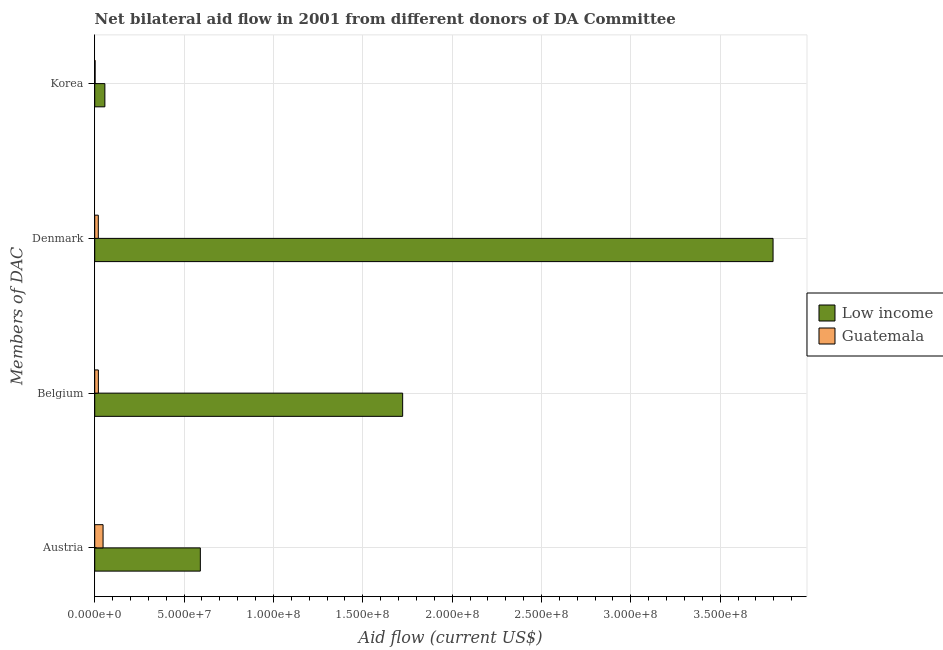Are the number of bars per tick equal to the number of legend labels?
Your answer should be very brief. Yes. How many bars are there on the 1st tick from the bottom?
Give a very brief answer. 2. What is the amount of aid given by denmark in Low income?
Offer a very short reply. 3.80e+08. Across all countries, what is the maximum amount of aid given by austria?
Your answer should be compact. 5.91e+07. Across all countries, what is the minimum amount of aid given by belgium?
Make the answer very short. 2.04e+06. In which country was the amount of aid given by denmark minimum?
Your answer should be compact. Guatemala. What is the total amount of aid given by korea in the graph?
Keep it short and to the point. 5.89e+06. What is the difference between the amount of aid given by denmark in Guatemala and that in Low income?
Provide a short and direct response. -3.78e+08. What is the difference between the amount of aid given by austria in Low income and the amount of aid given by belgium in Guatemala?
Keep it short and to the point. 5.71e+07. What is the average amount of aid given by denmark per country?
Keep it short and to the point. 1.91e+08. What is the difference between the amount of aid given by korea and amount of aid given by belgium in Guatemala?
Make the answer very short. -1.83e+06. What is the ratio of the amount of aid given by austria in Guatemala to that in Low income?
Provide a short and direct response. 0.08. Is the difference between the amount of aid given by austria in Guatemala and Low income greater than the difference between the amount of aid given by denmark in Guatemala and Low income?
Your answer should be compact. Yes. What is the difference between the highest and the second highest amount of aid given by austria?
Ensure brevity in your answer.  5.44e+07. What is the difference between the highest and the lowest amount of aid given by denmark?
Provide a succinct answer. 3.78e+08. In how many countries, is the amount of aid given by austria greater than the average amount of aid given by austria taken over all countries?
Provide a short and direct response. 1. Is the sum of the amount of aid given by belgium in Guatemala and Low income greater than the maximum amount of aid given by korea across all countries?
Keep it short and to the point. Yes. Is it the case that in every country, the sum of the amount of aid given by korea and amount of aid given by austria is greater than the sum of amount of aid given by belgium and amount of aid given by denmark?
Your answer should be very brief. No. What does the 2nd bar from the top in Korea represents?
Make the answer very short. Low income. Are all the bars in the graph horizontal?
Give a very brief answer. Yes. Does the graph contain any zero values?
Give a very brief answer. No. Where does the legend appear in the graph?
Your answer should be very brief. Center right. How many legend labels are there?
Offer a terse response. 2. What is the title of the graph?
Your response must be concise. Net bilateral aid flow in 2001 from different donors of DA Committee. Does "Marshall Islands" appear as one of the legend labels in the graph?
Your answer should be very brief. No. What is the label or title of the Y-axis?
Offer a terse response. Members of DAC. What is the Aid flow (current US$) in Low income in Austria?
Offer a terse response. 5.91e+07. What is the Aid flow (current US$) in Guatemala in Austria?
Offer a very short reply. 4.66e+06. What is the Aid flow (current US$) of Low income in Belgium?
Keep it short and to the point. 1.72e+08. What is the Aid flow (current US$) in Guatemala in Belgium?
Keep it short and to the point. 2.04e+06. What is the Aid flow (current US$) in Low income in Denmark?
Give a very brief answer. 3.80e+08. What is the Aid flow (current US$) in Guatemala in Denmark?
Your answer should be very brief. 2.00e+06. What is the Aid flow (current US$) in Low income in Korea?
Your response must be concise. 5.68e+06. Across all Members of DAC, what is the maximum Aid flow (current US$) of Low income?
Offer a terse response. 3.80e+08. Across all Members of DAC, what is the maximum Aid flow (current US$) in Guatemala?
Offer a terse response. 4.66e+06. Across all Members of DAC, what is the minimum Aid flow (current US$) in Low income?
Your answer should be very brief. 5.68e+06. Across all Members of DAC, what is the minimum Aid flow (current US$) of Guatemala?
Offer a very short reply. 2.10e+05. What is the total Aid flow (current US$) of Low income in the graph?
Provide a succinct answer. 6.17e+08. What is the total Aid flow (current US$) of Guatemala in the graph?
Your answer should be compact. 8.91e+06. What is the difference between the Aid flow (current US$) of Low income in Austria and that in Belgium?
Make the answer very short. -1.13e+08. What is the difference between the Aid flow (current US$) of Guatemala in Austria and that in Belgium?
Offer a terse response. 2.62e+06. What is the difference between the Aid flow (current US$) in Low income in Austria and that in Denmark?
Your response must be concise. -3.20e+08. What is the difference between the Aid flow (current US$) of Guatemala in Austria and that in Denmark?
Provide a short and direct response. 2.66e+06. What is the difference between the Aid flow (current US$) in Low income in Austria and that in Korea?
Make the answer very short. 5.34e+07. What is the difference between the Aid flow (current US$) in Guatemala in Austria and that in Korea?
Offer a very short reply. 4.45e+06. What is the difference between the Aid flow (current US$) in Low income in Belgium and that in Denmark?
Keep it short and to the point. -2.07e+08. What is the difference between the Aid flow (current US$) of Low income in Belgium and that in Korea?
Provide a short and direct response. 1.67e+08. What is the difference between the Aid flow (current US$) in Guatemala in Belgium and that in Korea?
Your answer should be compact. 1.83e+06. What is the difference between the Aid flow (current US$) of Low income in Denmark and that in Korea?
Your response must be concise. 3.74e+08. What is the difference between the Aid flow (current US$) in Guatemala in Denmark and that in Korea?
Offer a terse response. 1.79e+06. What is the difference between the Aid flow (current US$) of Low income in Austria and the Aid flow (current US$) of Guatemala in Belgium?
Your answer should be very brief. 5.71e+07. What is the difference between the Aid flow (current US$) of Low income in Austria and the Aid flow (current US$) of Guatemala in Denmark?
Your response must be concise. 5.71e+07. What is the difference between the Aid flow (current US$) in Low income in Austria and the Aid flow (current US$) in Guatemala in Korea?
Provide a short and direct response. 5.89e+07. What is the difference between the Aid flow (current US$) in Low income in Belgium and the Aid flow (current US$) in Guatemala in Denmark?
Your response must be concise. 1.70e+08. What is the difference between the Aid flow (current US$) in Low income in Belgium and the Aid flow (current US$) in Guatemala in Korea?
Ensure brevity in your answer.  1.72e+08. What is the difference between the Aid flow (current US$) in Low income in Denmark and the Aid flow (current US$) in Guatemala in Korea?
Provide a short and direct response. 3.79e+08. What is the average Aid flow (current US$) in Low income per Members of DAC?
Your response must be concise. 1.54e+08. What is the average Aid flow (current US$) of Guatemala per Members of DAC?
Your answer should be compact. 2.23e+06. What is the difference between the Aid flow (current US$) of Low income and Aid flow (current US$) of Guatemala in Austria?
Your answer should be very brief. 5.44e+07. What is the difference between the Aid flow (current US$) of Low income and Aid flow (current US$) of Guatemala in Belgium?
Provide a succinct answer. 1.70e+08. What is the difference between the Aid flow (current US$) of Low income and Aid flow (current US$) of Guatemala in Denmark?
Provide a succinct answer. 3.78e+08. What is the difference between the Aid flow (current US$) of Low income and Aid flow (current US$) of Guatemala in Korea?
Your answer should be very brief. 5.47e+06. What is the ratio of the Aid flow (current US$) of Low income in Austria to that in Belgium?
Your response must be concise. 0.34. What is the ratio of the Aid flow (current US$) in Guatemala in Austria to that in Belgium?
Provide a succinct answer. 2.28. What is the ratio of the Aid flow (current US$) in Low income in Austria to that in Denmark?
Your answer should be compact. 0.16. What is the ratio of the Aid flow (current US$) of Guatemala in Austria to that in Denmark?
Your answer should be very brief. 2.33. What is the ratio of the Aid flow (current US$) in Low income in Austria to that in Korea?
Your answer should be very brief. 10.4. What is the ratio of the Aid flow (current US$) of Guatemala in Austria to that in Korea?
Make the answer very short. 22.19. What is the ratio of the Aid flow (current US$) of Low income in Belgium to that in Denmark?
Make the answer very short. 0.45. What is the ratio of the Aid flow (current US$) of Low income in Belgium to that in Korea?
Provide a succinct answer. 30.33. What is the ratio of the Aid flow (current US$) of Guatemala in Belgium to that in Korea?
Provide a succinct answer. 9.71. What is the ratio of the Aid flow (current US$) of Low income in Denmark to that in Korea?
Ensure brevity in your answer.  66.83. What is the ratio of the Aid flow (current US$) in Guatemala in Denmark to that in Korea?
Keep it short and to the point. 9.52. What is the difference between the highest and the second highest Aid flow (current US$) in Low income?
Your answer should be compact. 2.07e+08. What is the difference between the highest and the second highest Aid flow (current US$) of Guatemala?
Your answer should be very brief. 2.62e+06. What is the difference between the highest and the lowest Aid flow (current US$) in Low income?
Give a very brief answer. 3.74e+08. What is the difference between the highest and the lowest Aid flow (current US$) in Guatemala?
Your answer should be compact. 4.45e+06. 